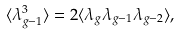<formula> <loc_0><loc_0><loc_500><loc_500>\langle \lambda _ { g - 1 } ^ { 3 } \rangle = 2 \langle \lambda _ { g } \lambda _ { g - 1 } \lambda _ { g - 2 } \rangle ,</formula> 